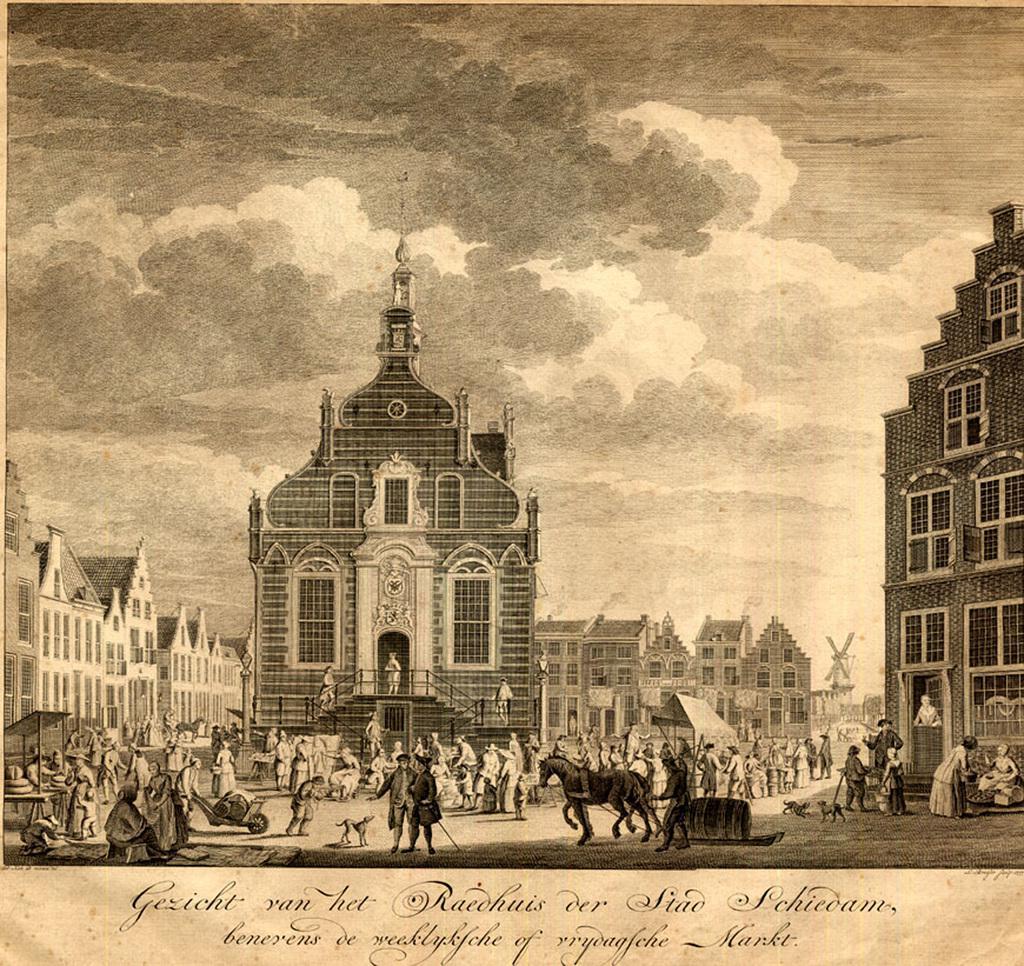Can you describe this image briefly? In this image we can see the poster with buildings and we can see the persons standing on the ground and there are vehicles. There are horses, animals, stairs and there is the text written on the poster. 